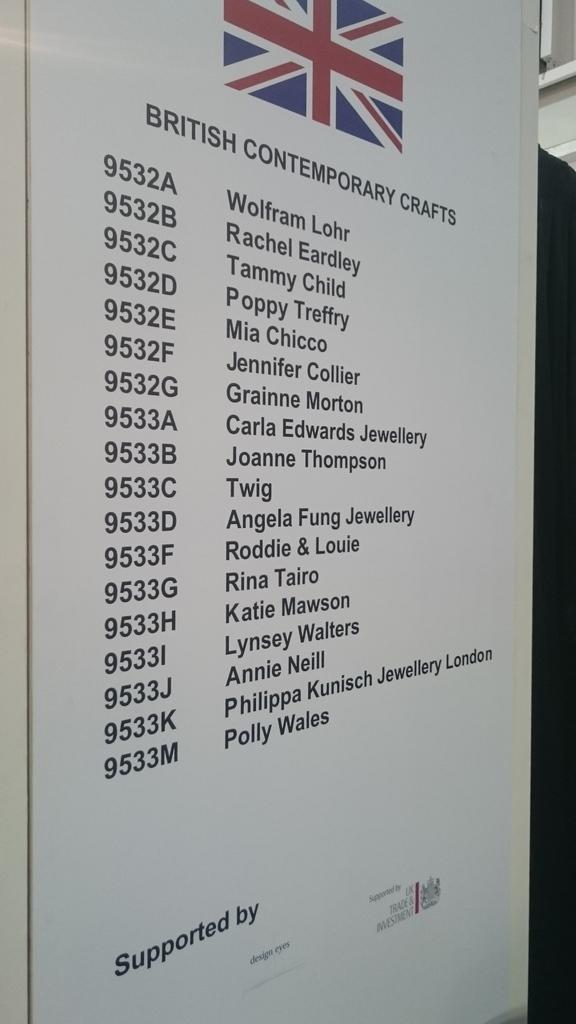<image>
Create a compact narrative representing the image presented. A British Contemporary Crafts list includes Twig and Jennifer Collier. 